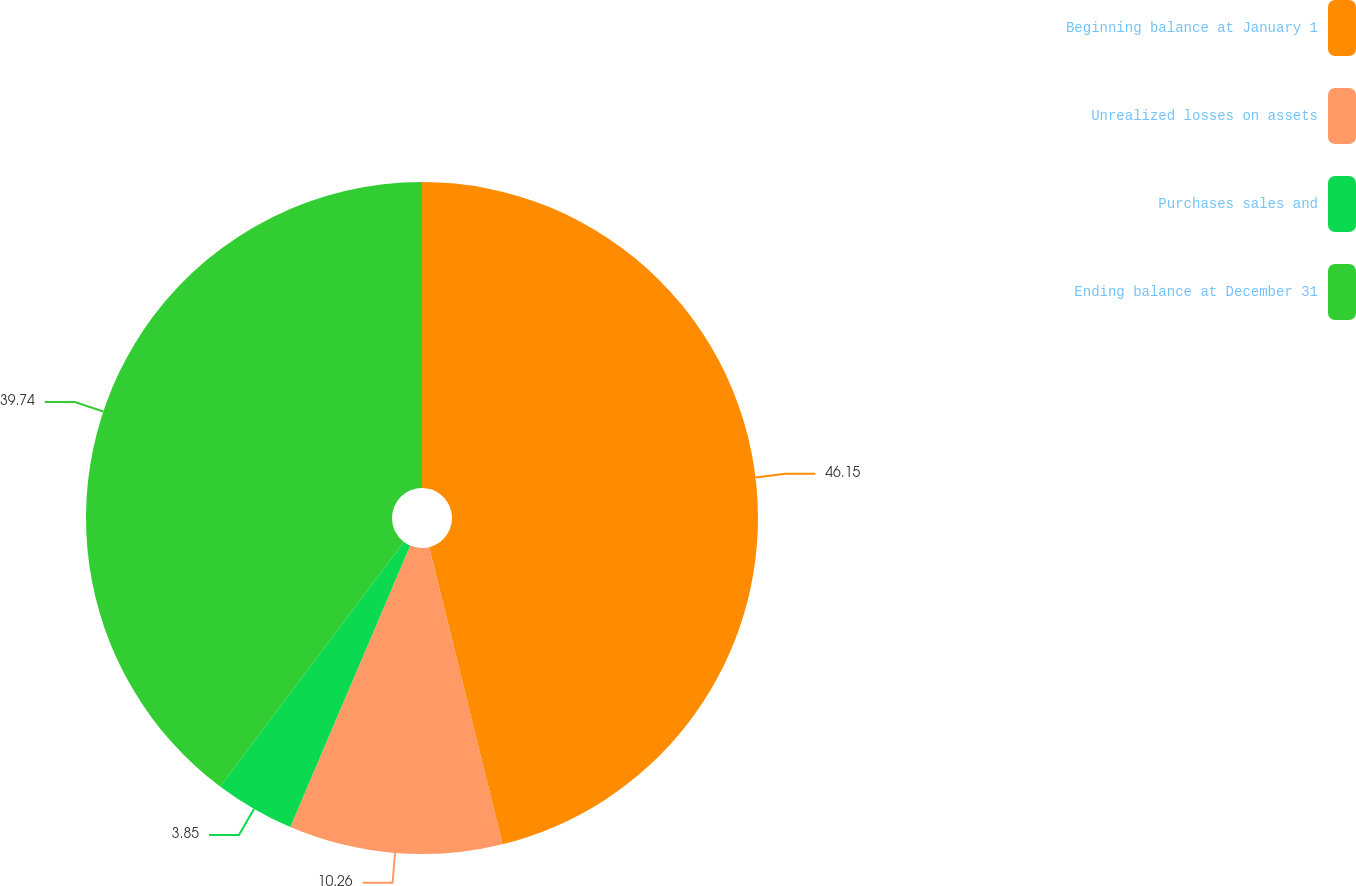<chart> <loc_0><loc_0><loc_500><loc_500><pie_chart><fcel>Beginning balance at January 1<fcel>Unrealized losses on assets<fcel>Purchases sales and<fcel>Ending balance at December 31<nl><fcel>46.15%<fcel>10.26%<fcel>3.85%<fcel>39.74%<nl></chart> 